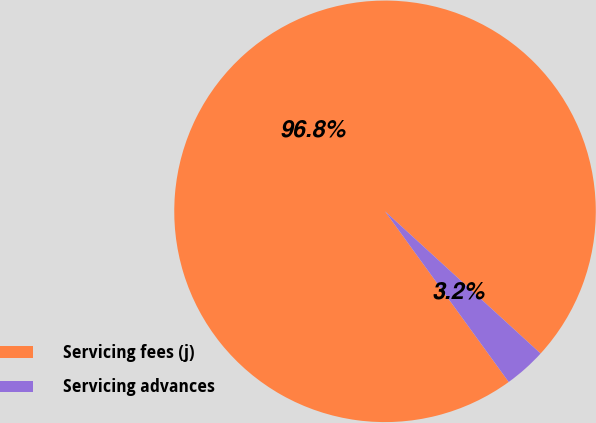Convert chart to OTSL. <chart><loc_0><loc_0><loc_500><loc_500><pie_chart><fcel>Servicing fees (j)<fcel>Servicing advances<nl><fcel>96.77%<fcel>3.23%<nl></chart> 